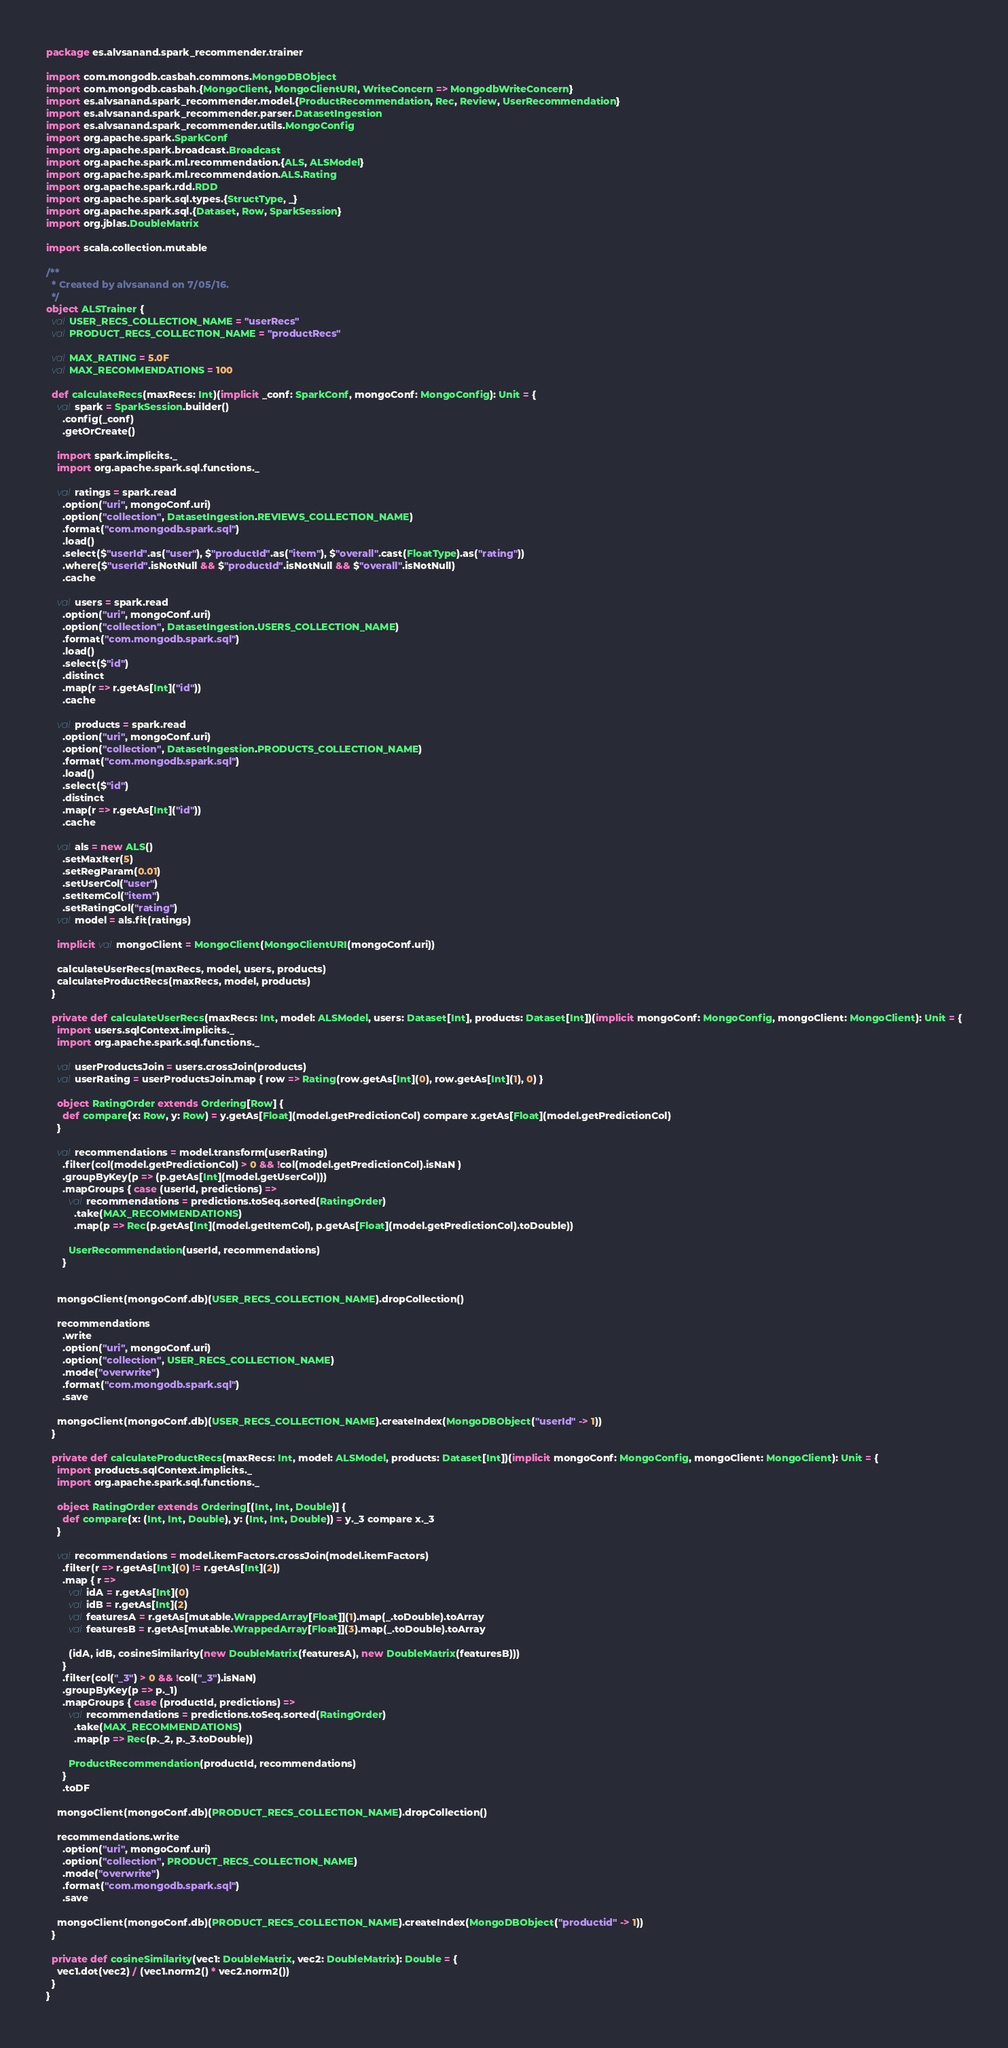<code> <loc_0><loc_0><loc_500><loc_500><_Scala_>package es.alvsanand.spark_recommender.trainer

import com.mongodb.casbah.commons.MongoDBObject
import com.mongodb.casbah.{MongoClient, MongoClientURI, WriteConcern => MongodbWriteConcern}
import es.alvsanand.spark_recommender.model.{ProductRecommendation, Rec, Review, UserRecommendation}
import es.alvsanand.spark_recommender.parser.DatasetIngestion
import es.alvsanand.spark_recommender.utils.MongoConfig
import org.apache.spark.SparkConf
import org.apache.spark.broadcast.Broadcast
import org.apache.spark.ml.recommendation.{ALS, ALSModel}
import org.apache.spark.ml.recommendation.ALS.Rating
import org.apache.spark.rdd.RDD
import org.apache.spark.sql.types.{StructType, _}
import org.apache.spark.sql.{Dataset, Row, SparkSession}
import org.jblas.DoubleMatrix

import scala.collection.mutable

/**
  * Created by alvsanand on 7/05/16.
  */
object ALSTrainer {
  val USER_RECS_COLLECTION_NAME = "userRecs"
  val PRODUCT_RECS_COLLECTION_NAME = "productRecs"

  val MAX_RATING = 5.0F
  val MAX_RECOMMENDATIONS = 100

  def calculateRecs(maxRecs: Int)(implicit _conf: SparkConf, mongoConf: MongoConfig): Unit = {
    val spark = SparkSession.builder()
      .config(_conf)
      .getOrCreate()

    import spark.implicits._
    import org.apache.spark.sql.functions._

    val ratings = spark.read
      .option("uri", mongoConf.uri)
      .option("collection", DatasetIngestion.REVIEWS_COLLECTION_NAME)
      .format("com.mongodb.spark.sql")
      .load()
      .select($"userId".as("user"), $"productId".as("item"), $"overall".cast(FloatType).as("rating"))
      .where($"userId".isNotNull && $"productId".isNotNull && $"overall".isNotNull)
      .cache

    val users = spark.read
      .option("uri", mongoConf.uri)
      .option("collection", DatasetIngestion.USERS_COLLECTION_NAME)
      .format("com.mongodb.spark.sql")
      .load()
      .select($"id")
      .distinct
      .map(r => r.getAs[Int]("id"))
      .cache

    val products = spark.read
      .option("uri", mongoConf.uri)
      .option("collection", DatasetIngestion.PRODUCTS_COLLECTION_NAME)
      .format("com.mongodb.spark.sql")
      .load()
      .select($"id")
      .distinct
      .map(r => r.getAs[Int]("id"))
      .cache

    val als = new ALS()
      .setMaxIter(5)
      .setRegParam(0.01)
      .setUserCol("user")
      .setItemCol("item")
      .setRatingCol("rating")
    val model = als.fit(ratings)

    implicit val mongoClient = MongoClient(MongoClientURI(mongoConf.uri))

    calculateUserRecs(maxRecs, model, users, products)
    calculateProductRecs(maxRecs, model, products)
  }

  private def calculateUserRecs(maxRecs: Int, model: ALSModel, users: Dataset[Int], products: Dataset[Int])(implicit mongoConf: MongoConfig, mongoClient: MongoClient): Unit = {
    import users.sqlContext.implicits._
    import org.apache.spark.sql.functions._

    val userProductsJoin = users.crossJoin(products)
    val userRating = userProductsJoin.map { row => Rating(row.getAs[Int](0), row.getAs[Int](1), 0) }

    object RatingOrder extends Ordering[Row] {
      def compare(x: Row, y: Row) = y.getAs[Float](model.getPredictionCol) compare x.getAs[Float](model.getPredictionCol)
    }

    val recommendations = model.transform(userRating)
      .filter(col(model.getPredictionCol) > 0 && !col(model.getPredictionCol).isNaN )
      .groupByKey(p => (p.getAs[Int](model.getUserCol)))
      .mapGroups { case (userId, predictions) =>
        val recommendations = predictions.toSeq.sorted(RatingOrder)
          .take(MAX_RECOMMENDATIONS)
          .map(p => Rec(p.getAs[Int](model.getItemCol), p.getAs[Float](model.getPredictionCol).toDouble))

        UserRecommendation(userId, recommendations)
      }


    mongoClient(mongoConf.db)(USER_RECS_COLLECTION_NAME).dropCollection()

    recommendations
      .write
      .option("uri", mongoConf.uri)
      .option("collection", USER_RECS_COLLECTION_NAME)
      .mode("overwrite")
      .format("com.mongodb.spark.sql")
      .save

    mongoClient(mongoConf.db)(USER_RECS_COLLECTION_NAME).createIndex(MongoDBObject("userId" -> 1))
  }

  private def calculateProductRecs(maxRecs: Int, model: ALSModel, products: Dataset[Int])(implicit mongoConf: MongoConfig, mongoClient: MongoClient): Unit = {
    import products.sqlContext.implicits._
    import org.apache.spark.sql.functions._

    object RatingOrder extends Ordering[(Int, Int, Double)] {
      def compare(x: (Int, Int, Double), y: (Int, Int, Double)) = y._3 compare x._3
    }

    val recommendations = model.itemFactors.crossJoin(model.itemFactors)
      .filter(r => r.getAs[Int](0) != r.getAs[Int](2))
      .map { r =>
        val idA = r.getAs[Int](0)
        val idB = r.getAs[Int](2)
        val featuresA = r.getAs[mutable.WrappedArray[Float]](1).map(_.toDouble).toArray
        val featuresB = r.getAs[mutable.WrappedArray[Float]](3).map(_.toDouble).toArray

        (idA, idB, cosineSimilarity(new DoubleMatrix(featuresA), new DoubleMatrix(featuresB)))
      }
      .filter(col("_3") > 0 && !col("_3").isNaN)
      .groupByKey(p => p._1)
      .mapGroups { case (productId, predictions) =>
        val recommendations = predictions.toSeq.sorted(RatingOrder)
          .take(MAX_RECOMMENDATIONS)
          .map(p => Rec(p._2, p._3.toDouble))

        ProductRecommendation(productId, recommendations)
      }
      .toDF

    mongoClient(mongoConf.db)(PRODUCT_RECS_COLLECTION_NAME).dropCollection()

    recommendations.write
      .option("uri", mongoConf.uri)
      .option("collection", PRODUCT_RECS_COLLECTION_NAME)
      .mode("overwrite")
      .format("com.mongodb.spark.sql")
      .save

    mongoClient(mongoConf.db)(PRODUCT_RECS_COLLECTION_NAME).createIndex(MongoDBObject("productid" -> 1))
  }

  private def cosineSimilarity(vec1: DoubleMatrix, vec2: DoubleMatrix): Double = {
    vec1.dot(vec2) / (vec1.norm2() * vec2.norm2())
  }
}
</code> 